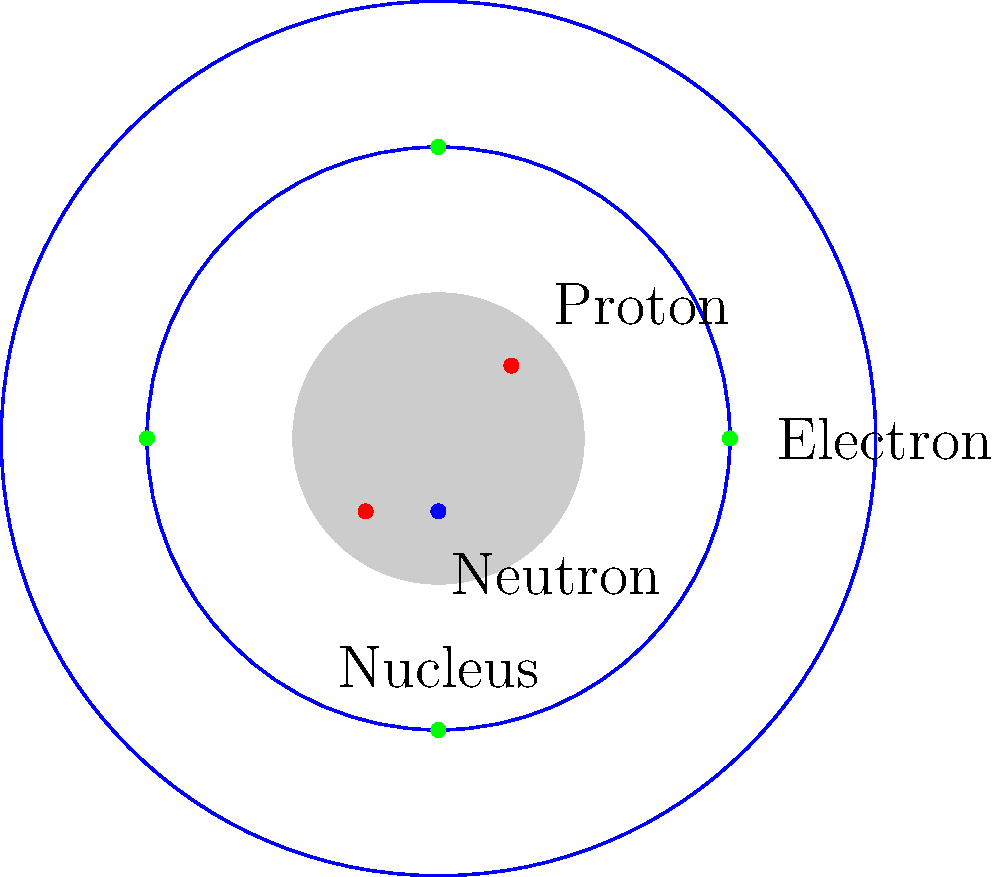In the simplified atomic model shown, how many more electrons would be needed to create a neutral atom if the nucleus contains 3 protons and 1 neutron? To determine how many more electrons are needed for a neutral atom, we need to follow these steps:

1. Understand the concept of a neutral atom:
   - In a neutral atom, the number of protons equals the number of electrons.

2. Count the number of protons in the nucleus:
   - The question states that there are 3 protons in the nucleus.

3. Count the number of electrons in the diagram:
   - The diagram shows 4 electrons (green dots) in the electron shells.

4. Calculate the difference:
   - Number of electrons needed = Number of protons - Number of electrons present
   - $3 - 4 = -1$

5. Interpret the result:
   - A negative result means there are more electrons than protons.
   - To achieve a neutral atom, we need to remove 1 electron, not add any.

This question encourages visual interpretation and simple arithmetic, which can be engaging for an autistic child while teaching basic atomic structure.
Answer: Remove 1 electron 